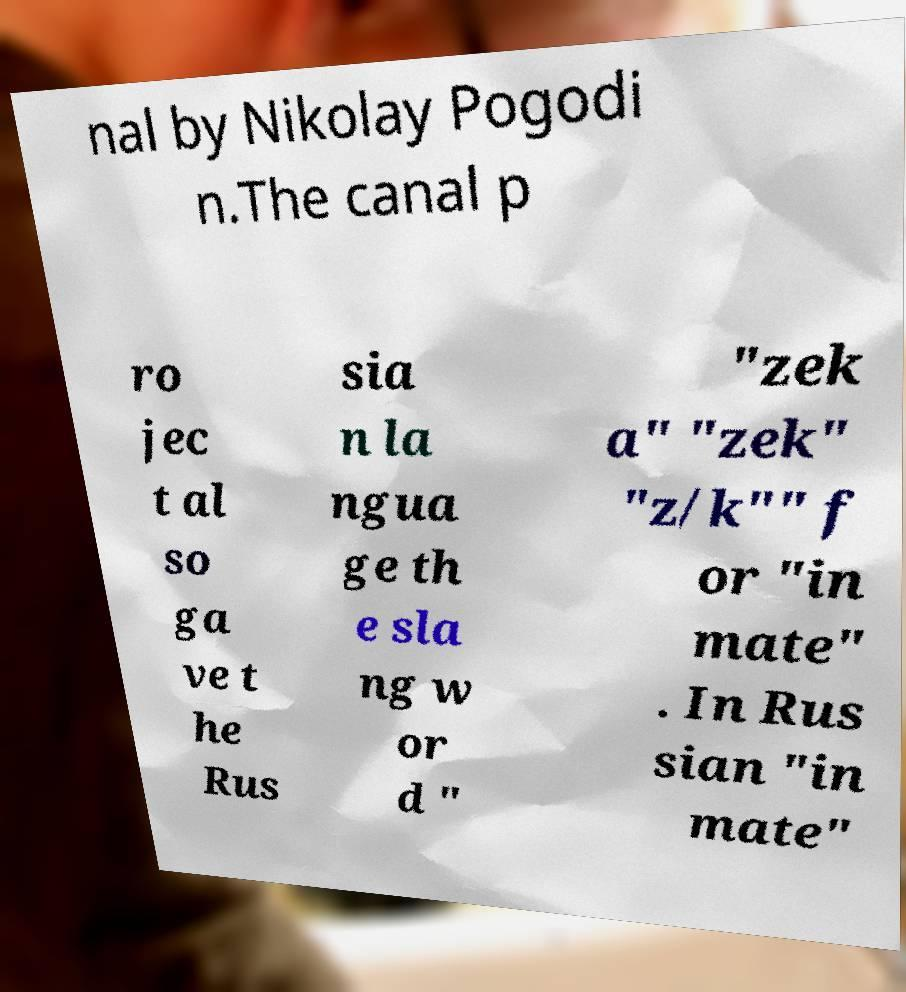I need the written content from this picture converted into text. Can you do that? nal by Nikolay Pogodi n.The canal p ro jec t al so ga ve t he Rus sia n la ngua ge th e sla ng w or d " "zek a" "zek" "z/k"" f or "in mate" . In Rus sian "in mate" 